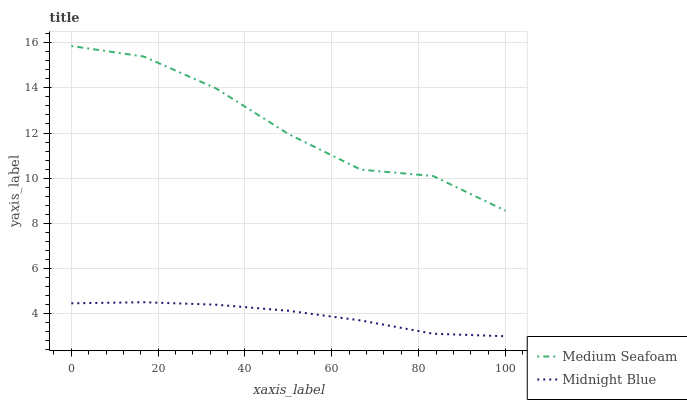Does Midnight Blue have the minimum area under the curve?
Answer yes or no. Yes. Does Medium Seafoam have the maximum area under the curve?
Answer yes or no. Yes. Does Midnight Blue have the maximum area under the curve?
Answer yes or no. No. Is Midnight Blue the smoothest?
Answer yes or no. Yes. Is Medium Seafoam the roughest?
Answer yes or no. Yes. Is Midnight Blue the roughest?
Answer yes or no. No. Does Midnight Blue have the lowest value?
Answer yes or no. Yes. Does Medium Seafoam have the highest value?
Answer yes or no. Yes. Does Midnight Blue have the highest value?
Answer yes or no. No. Is Midnight Blue less than Medium Seafoam?
Answer yes or no. Yes. Is Medium Seafoam greater than Midnight Blue?
Answer yes or no. Yes. Does Midnight Blue intersect Medium Seafoam?
Answer yes or no. No. 